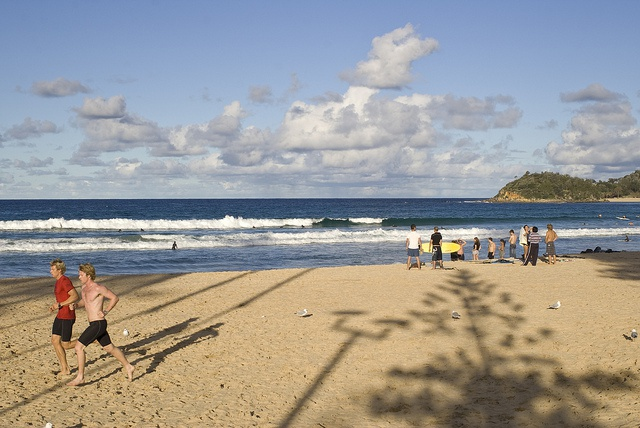Describe the objects in this image and their specific colors. I can see people in gray, tan, and black tones, people in gray, brown, black, and tan tones, people in gray, ivory, and tan tones, people in gray, black, and darkgray tones, and people in gray, black, and tan tones in this image. 